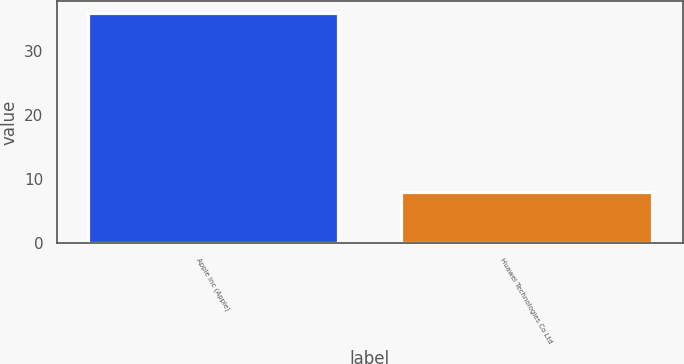Convert chart. <chart><loc_0><loc_0><loc_500><loc_500><bar_chart><fcel>Apple Inc (Apple)<fcel>Huawei Technologies Co Ltd<nl><fcel>36<fcel>8<nl></chart> 